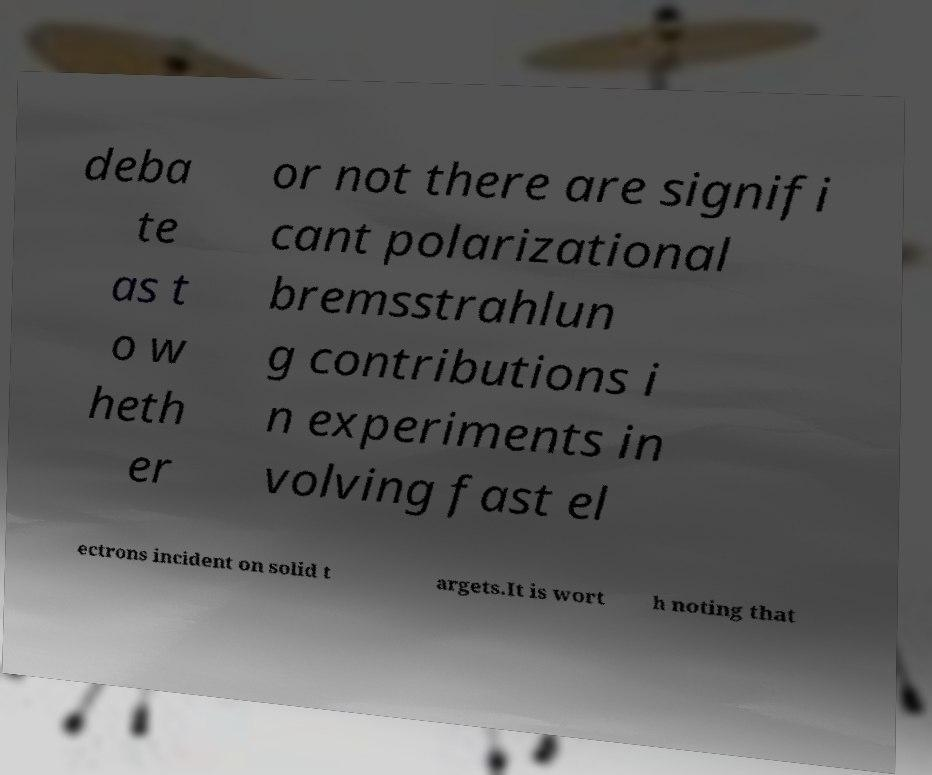For documentation purposes, I need the text within this image transcribed. Could you provide that? deba te as t o w heth er or not there are signifi cant polarizational bremsstrahlun g contributions i n experiments in volving fast el ectrons incident on solid t argets.It is wort h noting that 